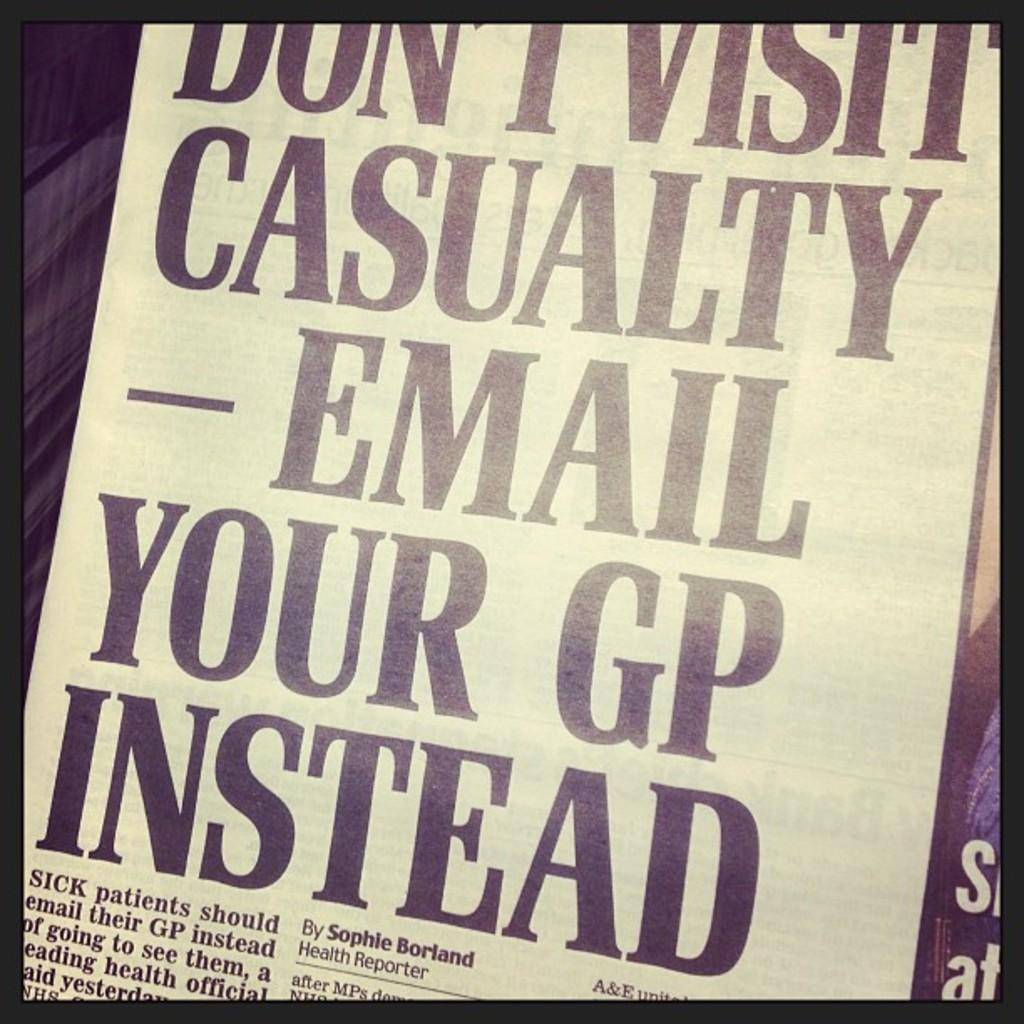<image>
Provide a brief description of the given image. A newspaper article about health written by Sophie Borland. 